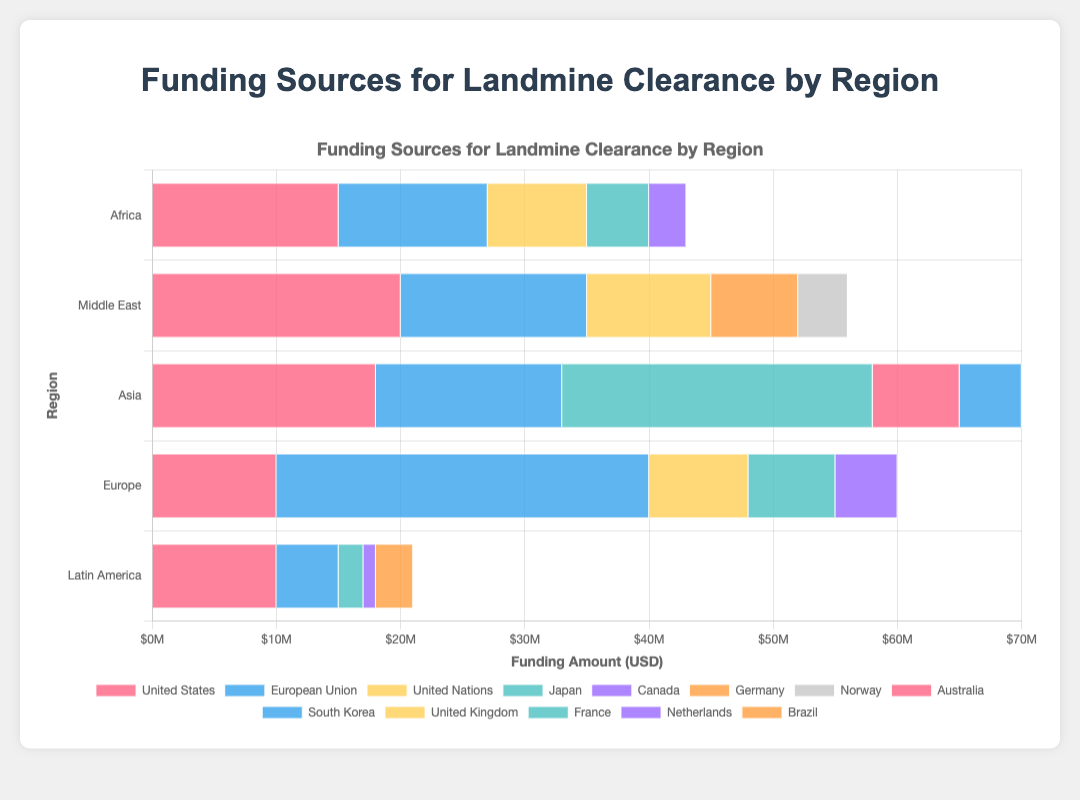Which region receives the highest total funding for landmine clearance? To determine the region with the highest total funding, sum the contributions from all sources for each region and compare the totals. For Africa, the total is $43 million; Middle East, $56 million; Asia, $70 million; Europe, $58 million; and Latin America, $22 million. Asia has the highest total funding with $70 million.
Answer: Asia How much more funding does Asia receive from Japan compared to the United States? Asia receives $25 million from Japan and $18 million from the United States. To find the difference, subtract $18 million from $25 million.
Answer: $7 million Which funding source has the lowest contribution in Europe? Examine the funding sources for Europe and identify the smallest value. The European Union provides $30 million, the United States $10 million, the United Kingdom $8 million, France $7 million, and the Netherlands $5 million. The Netherlands has the lowest contribution with $5 million.
Answer: Netherlands What is the combined total funding from the United States across all regions? To find the combined total, add the contributions from the United States for each region: Africa ($15 million), Middle East ($20 million), Asia ($18 million), Europe ($10 million), and Latin America ($10 million). The total is $15 million + $20 million + $18 million + $10 million + $10 million, which equals $73 million.
Answer: $73 million Compare the funding from the European Union in Africa and Latin America. Which region receives more and by how much? Africa receives $12 million from the European Union, while Latin America receives $5 million. To find which region receives more, compare these two amounts. Subtract $5 million from $12 million to find the difference.
Answer: Africa by $7 million What is the total funding for landmine clearance from Canada across all regions? Canada contributes $3 million to Africa and $1 million to Latin America. Add $3 million and $1 million to get the total funding from Canada.
Answer: $4 million Which region receives the least funding from the European Union, and how much is it? Compare the European Union funding across all regions: Africa ($12 million), Middle East ($15 million), Asia ($15 million), Europe ($30 million), and Latin America ($5 million). Latin America receives $5 million, which is the least amount.
Answer: Latin America, $5 million How does the funding in the Middle East from Norway compare to that from Germany? In the Middle East, Germany provides $7 million while Norway provides $4 million. Compare the two amounts to understand the difference. Germany provides more funding than Norway.
Answer: Germany provides more What is the average funding amount provided by the United Nations across all regions? The United Nations provides funding to Africa ($8 million), Middle East ($10 million), and does not provide funding to Asia, Europe, or Latin America. Sum the contributions: $8 million + $10 million equals $18 million. Divide by the number of regions funded (2 regions): $18 million / 2.
Answer: $9 million 